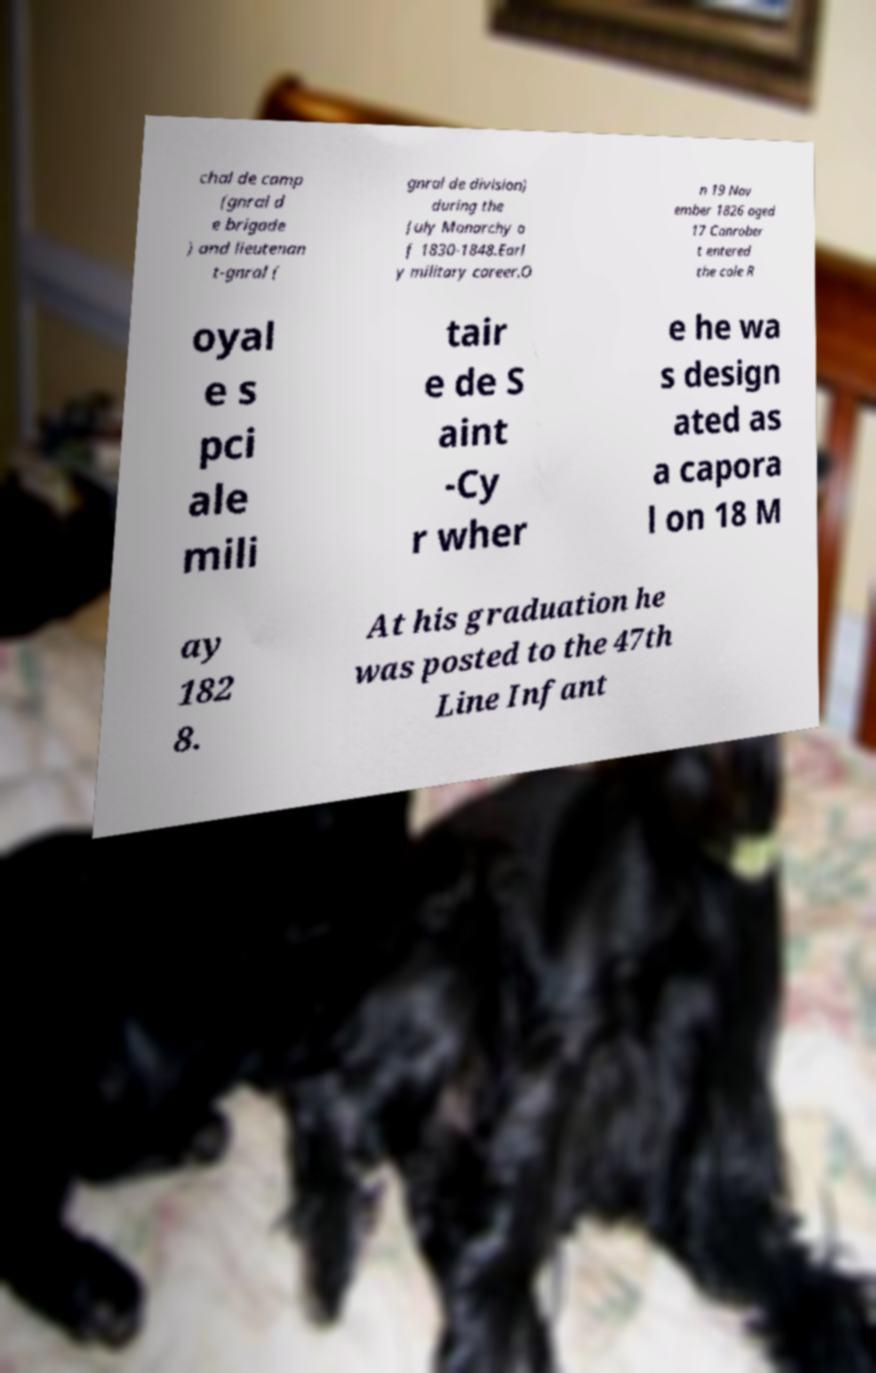What messages or text are displayed in this image? I need them in a readable, typed format. chal de camp (gnral d e brigade ) and lieutenan t-gnral ( gnral de division) during the July Monarchy o f 1830-1848.Earl y military career.O n 19 Nov ember 1826 aged 17 Canrober t entered the cole R oyal e s pci ale mili tair e de S aint -Cy r wher e he wa s design ated as a capora l on 18 M ay 182 8. At his graduation he was posted to the 47th Line Infant 